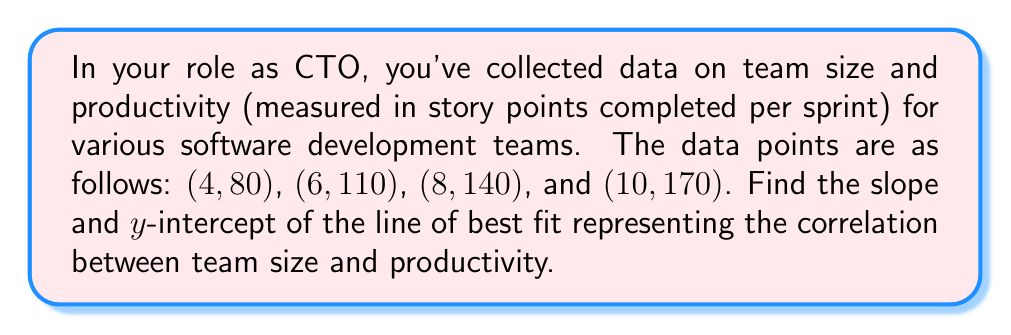Show me your answer to this math problem. To find the slope and y-intercept of the line of best fit, we'll use the formula for the slope-intercept form of a line: $y = mx + b$, where $m$ is the slope and $b$ is the y-intercept.

Step 1: Calculate the slope using the point-slope formula:
$$m = \frac{y_2 - y_1}{x_2 - x_1}$$

We'll use the first and last data points: (4, 80) and (10, 170)

$$m = \frac{170 - 80}{10 - 4} = \frac{90}{6} = 15$$

Step 2: Use the slope and one of the points to find the y-intercept:
$$y = mx + b$$
$$80 = 15(4) + b$$
$$80 = 60 + b$$
$$b = 80 - 60 = 20$$

Step 3: Write the equation of the line:
$$y = 15x + 20$$

Therefore, the slope is 15 and the y-intercept is 20.
Answer: Slope: 15, Y-intercept: 20 